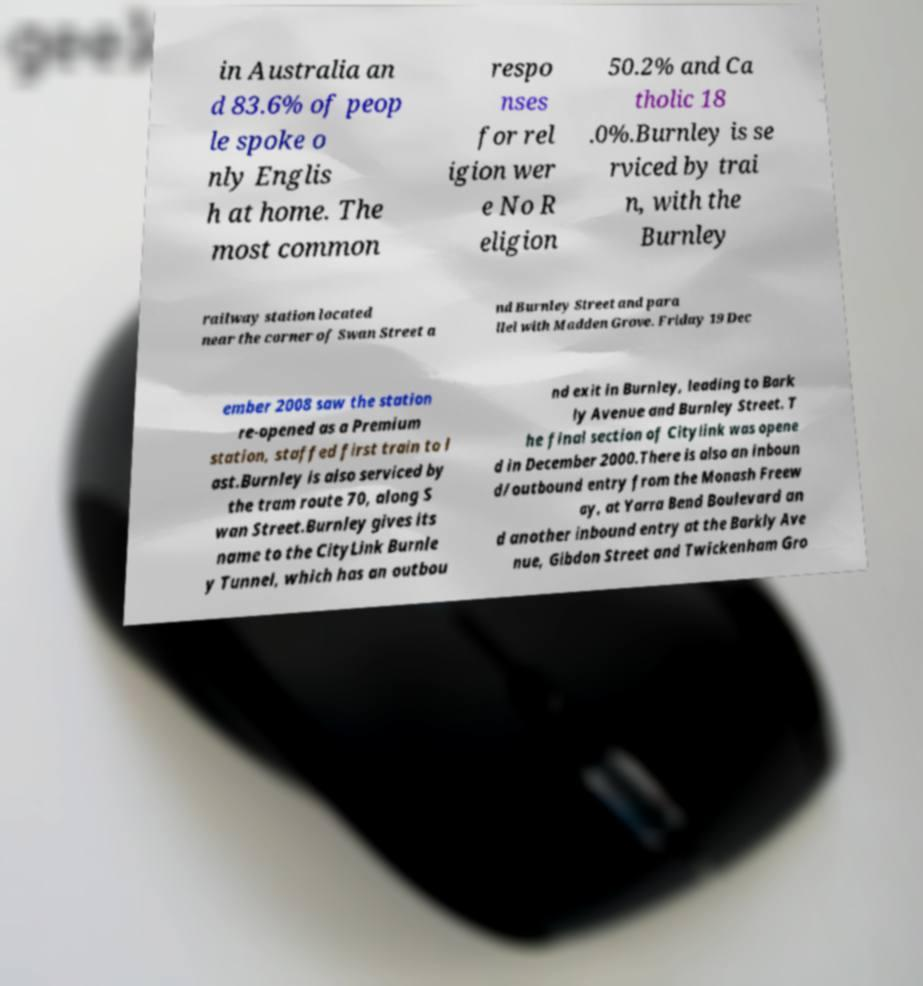Please read and relay the text visible in this image. What does it say? in Australia an d 83.6% of peop le spoke o nly Englis h at home. The most common respo nses for rel igion wer e No R eligion 50.2% and Ca tholic 18 .0%.Burnley is se rviced by trai n, with the Burnley railway station located near the corner of Swan Street a nd Burnley Street and para llel with Madden Grove. Friday 19 Dec ember 2008 saw the station re-opened as a Premium station, staffed first train to l ast.Burnley is also serviced by the tram route 70, along S wan Street.Burnley gives its name to the CityLink Burnle y Tunnel, which has an outbou nd exit in Burnley, leading to Bark ly Avenue and Burnley Street. T he final section of Citylink was opene d in December 2000.There is also an inboun d/outbound entry from the Monash Freew ay, at Yarra Bend Boulevard an d another inbound entry at the Barkly Ave nue, Gibdon Street and Twickenham Gro 